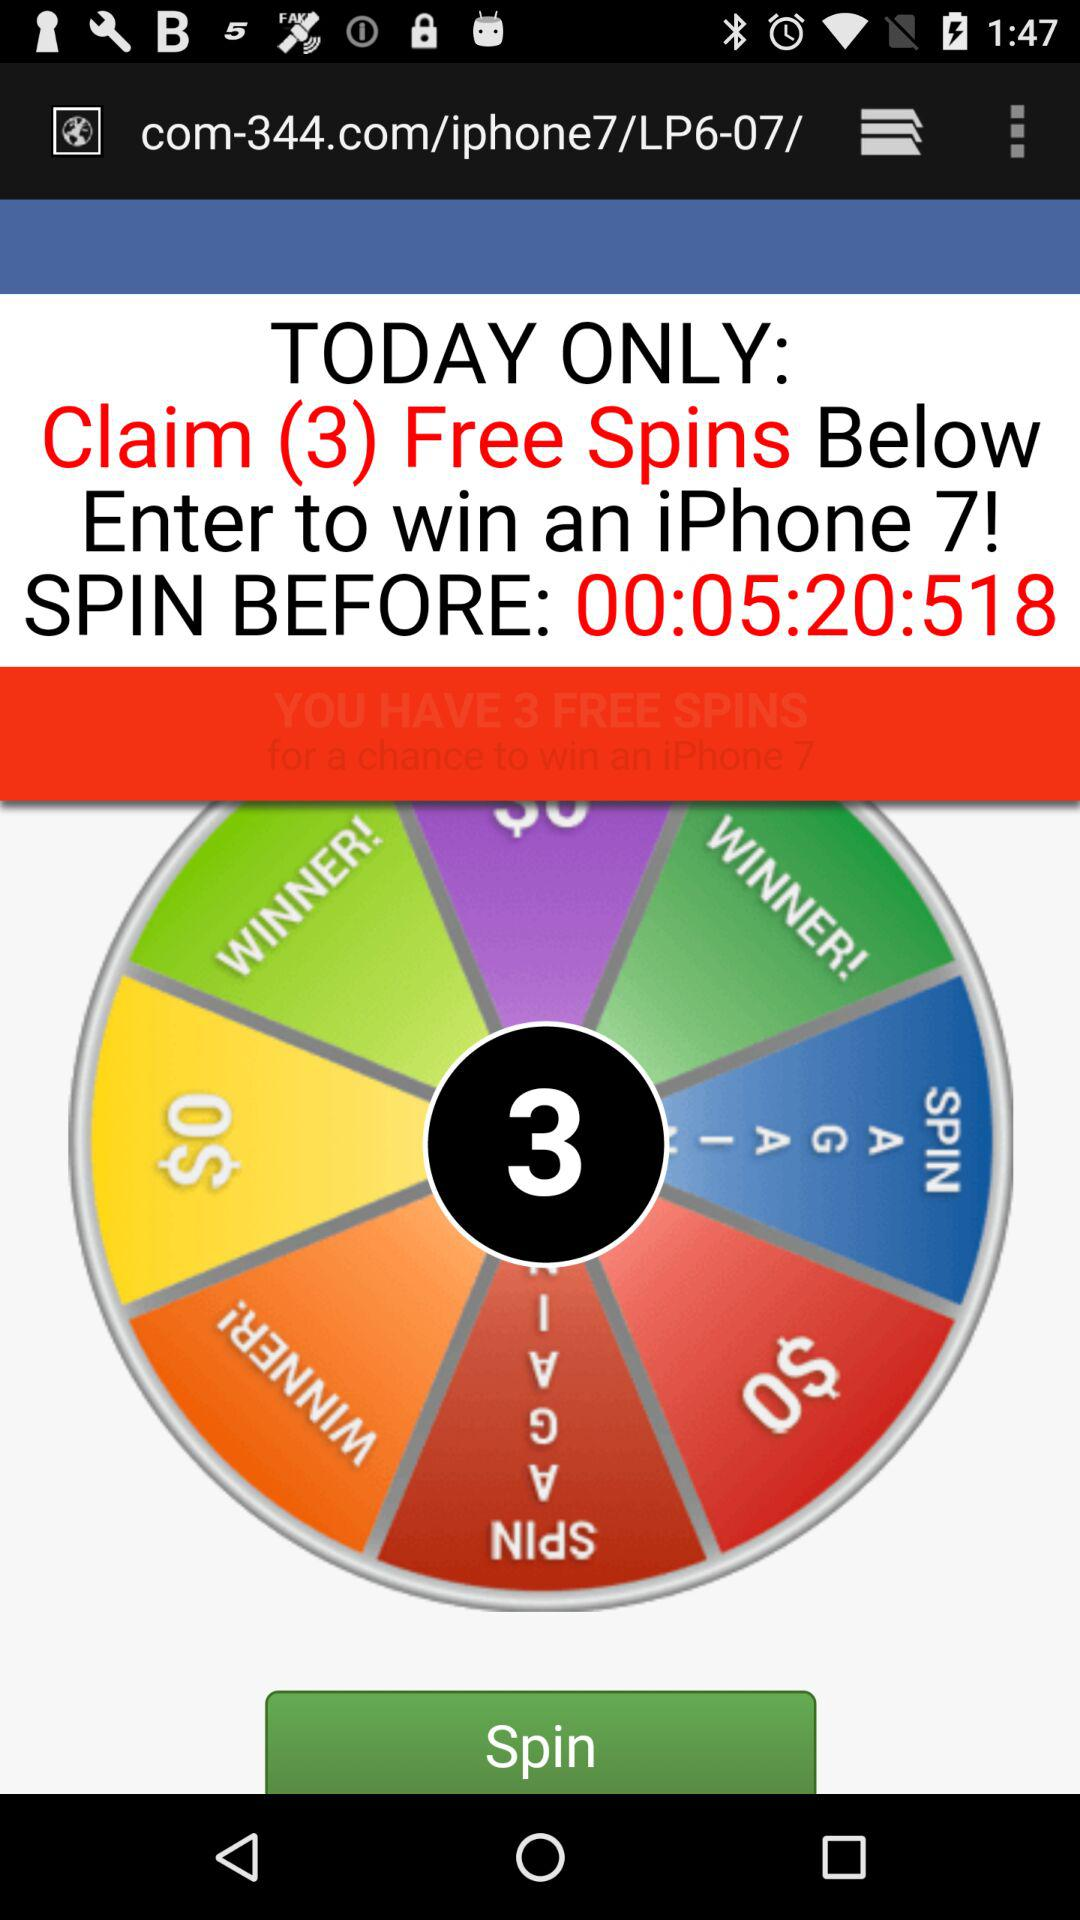How much time do I have to spin the wheel?
Answer the question using a single word or phrase. 00:05:20:518 